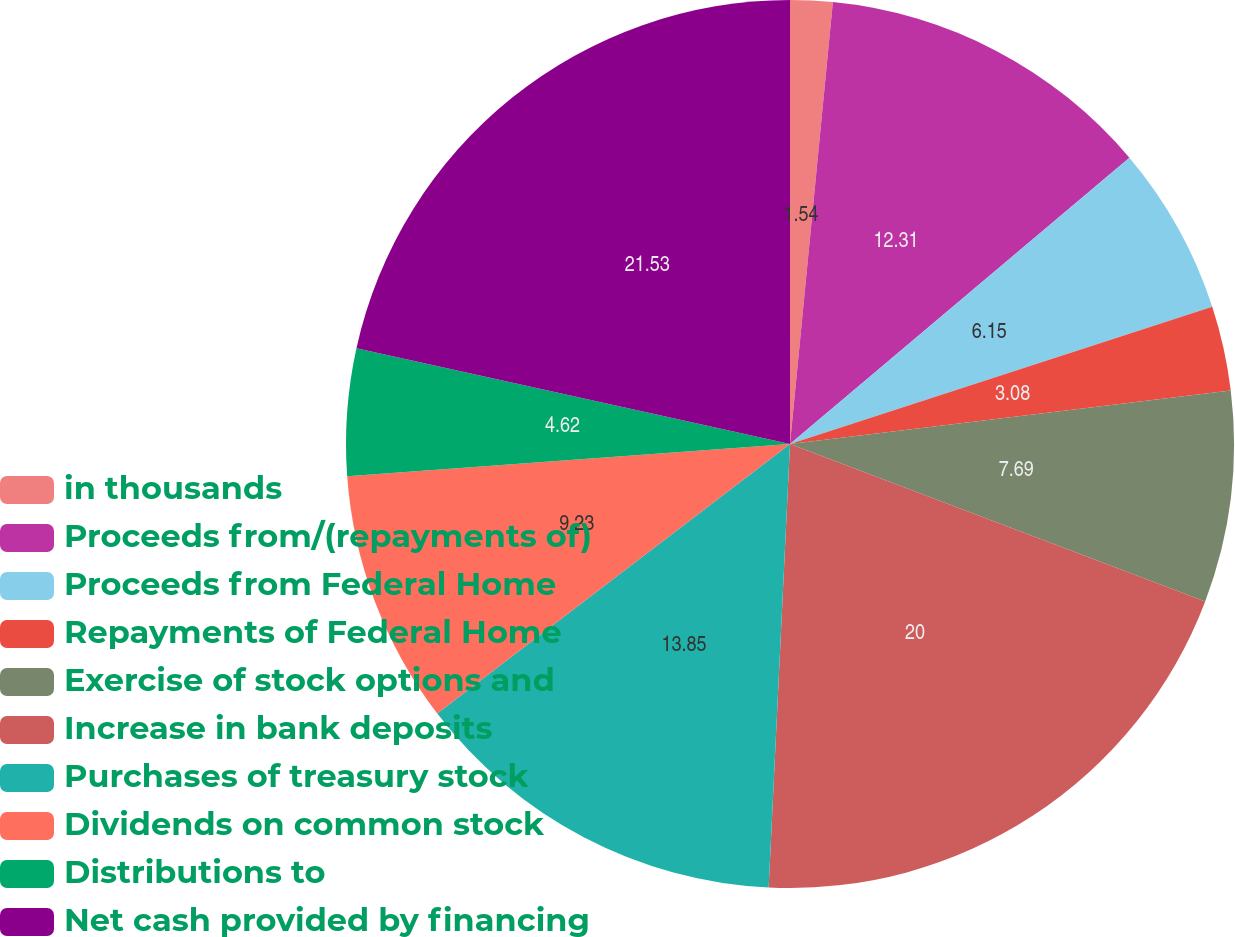Convert chart. <chart><loc_0><loc_0><loc_500><loc_500><pie_chart><fcel>in thousands<fcel>Proceeds from/(repayments of)<fcel>Proceeds from Federal Home<fcel>Repayments of Federal Home<fcel>Exercise of stock options and<fcel>Increase in bank deposits<fcel>Purchases of treasury stock<fcel>Dividends on common stock<fcel>Distributions to<fcel>Net cash provided by financing<nl><fcel>1.54%<fcel>12.31%<fcel>6.15%<fcel>3.08%<fcel>7.69%<fcel>20.0%<fcel>13.85%<fcel>9.23%<fcel>4.62%<fcel>21.54%<nl></chart> 